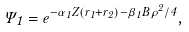<formula> <loc_0><loc_0><loc_500><loc_500>\Psi _ { 1 } = { e } ^ { - \alpha _ { 1 } Z ( r _ { 1 } + r _ { 2 } ) - \beta _ { 1 } B \rho ^ { 2 } / 4 } ,</formula> 